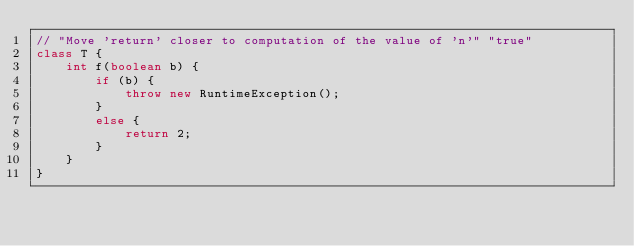Convert code to text. <code><loc_0><loc_0><loc_500><loc_500><_Java_>// "Move 'return' closer to computation of the value of 'n'" "true"
class T {
    int f(boolean b) {
        if (b) {
            throw new RuntimeException();
        }
        else {
            return 2;
        }
    }
}</code> 